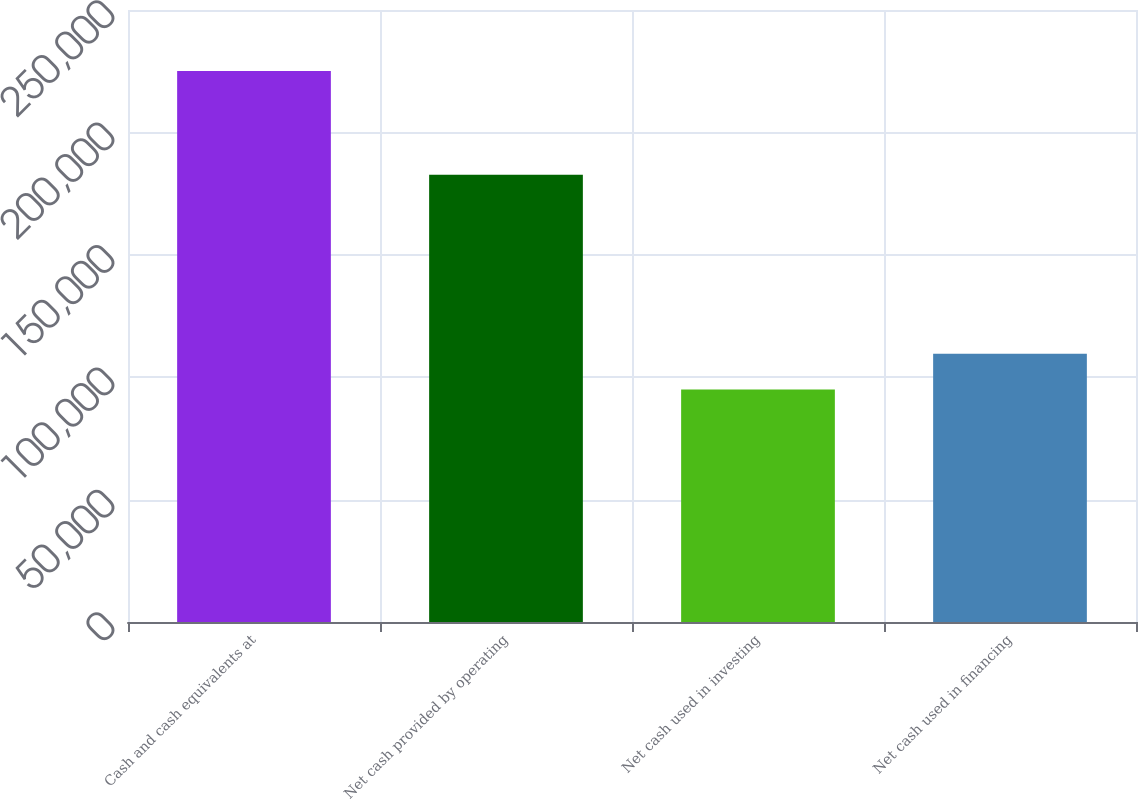Convert chart to OTSL. <chart><loc_0><loc_0><loc_500><loc_500><bar_chart><fcel>Cash and cash equivalents at<fcel>Net cash provided by operating<fcel>Net cash used in investing<fcel>Net cash used in financing<nl><fcel>225104<fcel>182673<fcel>94959<fcel>109621<nl></chart> 